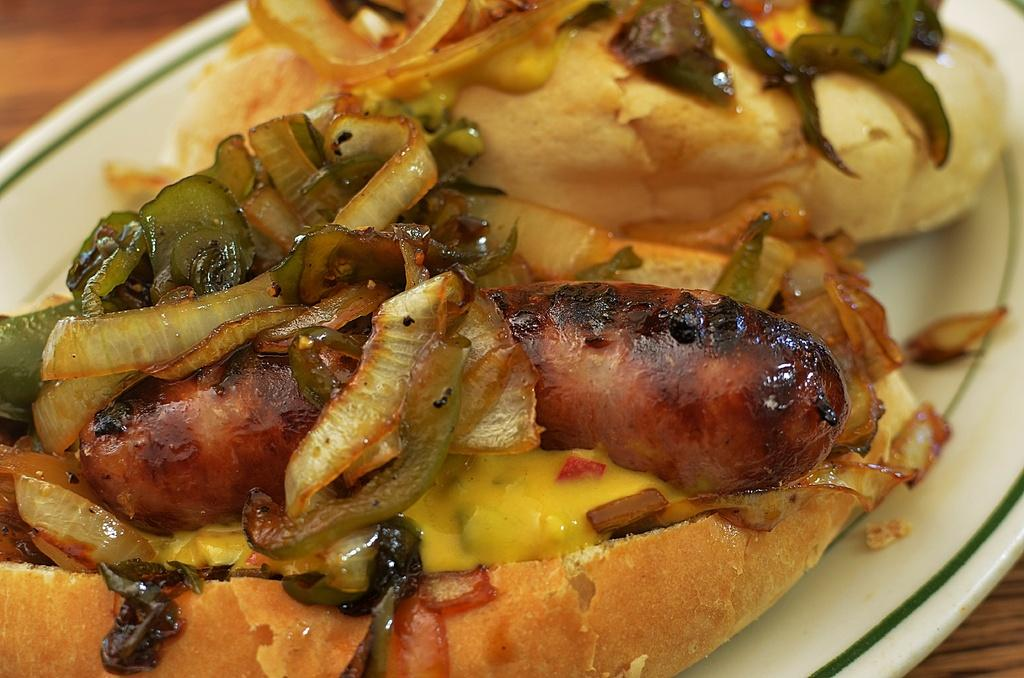What is present in the image that can be eaten? There is food in the image. How is the food arranged or contained? The food is in a plate. Where is the plate with food located? The plate is placed on a table. What type of trains can be seen passing by in the image? There are no trains present in the image; it only features food in a plate on a table. 